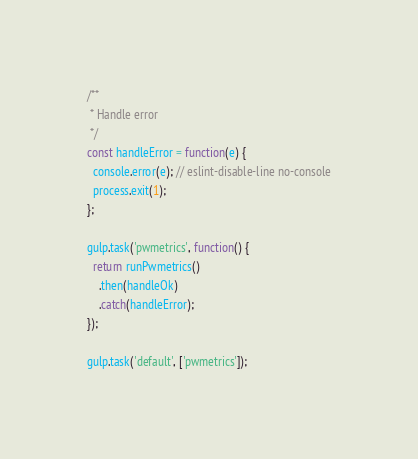<code> <loc_0><loc_0><loc_500><loc_500><_JavaScript_>
/**
 * Handle error
 */
const handleError = function(e) {
  console.error(e); // eslint-disable-line no-console
  process.exit(1);
};

gulp.task('pwmetrics', function() {
  return runPwmetrics()
    .then(handleOk)
    .catch(handleError);
});

gulp.task('default', ['pwmetrics']);
</code> 